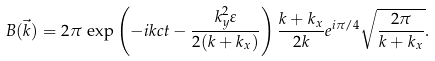Convert formula to latex. <formula><loc_0><loc_0><loc_500><loc_500>B ( \vec { k } ) = 2 \pi \, \exp { \left ( - i k c t - \frac { k _ { y } ^ { 2 } \varepsilon } { 2 ( k + k _ { x } ) } \right ) } \, \frac { k + k _ { x } } { 2 k } e ^ { i \pi / 4 } \sqrt { \frac { 2 \pi } { k + k _ { x } } } .</formula> 